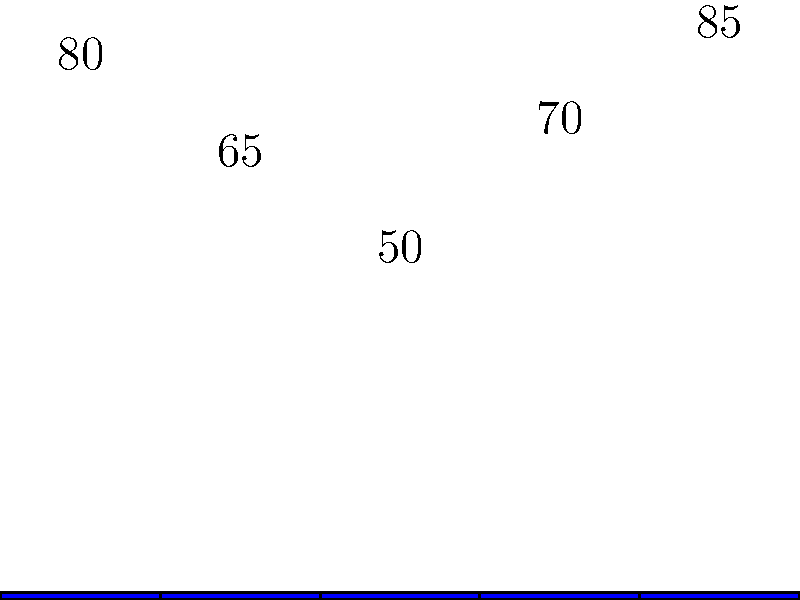Based on the frequency spectrum graph of Blue October's most popular songs, which frequency range shows the highest amplitude, potentially indicating where the band's signature sound is most prominent? To answer this question, we need to analyze the bar graph representing the frequency spectrum of Blue October's most popular songs. The graph shows five frequency ranges on the x-axis and their corresponding amplitudes as percentages on the y-axis. Let's examine each range:

1. 20-100Hz: This range has an amplitude of 80%
2. 100-500Hz: This range has an amplitude of 65%
3. 500Hz-1kHz: This range has an amplitude of 50%
4. 1-5kHz: This range has an amplitude of 70%
5. 5-20kHz: This range has an amplitude of 85%

By comparing these values, we can see that the highest amplitude is in the 5-20kHz range at 85%. This suggests that Blue October's signature sound is most prominent in the higher frequency range, which typically includes elements like cymbals, high-pitched synthesizers, and the upper harmonics of vocals and guitars.

It's worth noting that this high-frequency emphasis could contribute to the band's distinctive sound, potentially giving their music a brighter or more crisp quality. However, the relatively high amplitudes across all frequency ranges indicate a well-balanced mix, which is characteristic of professionally produced music.
Answer: 5-20kHz 